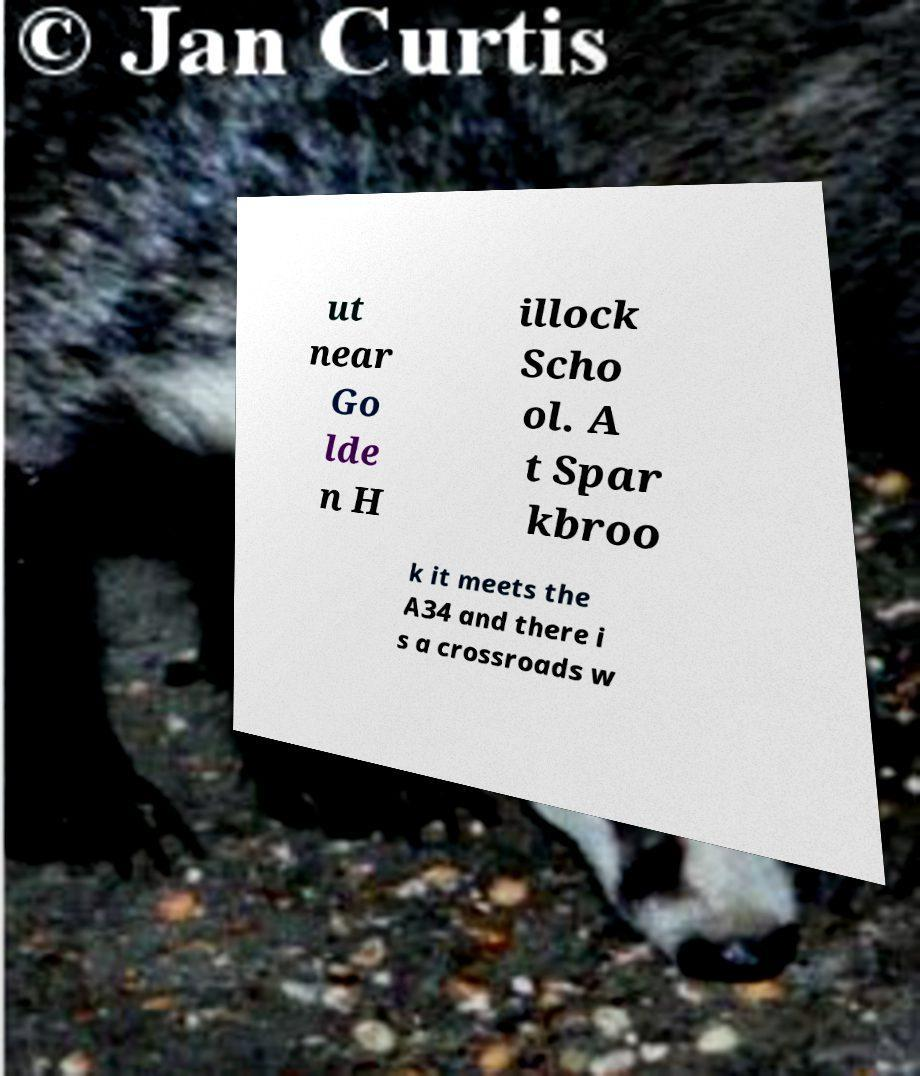There's text embedded in this image that I need extracted. Can you transcribe it verbatim? ut near Go lde n H illock Scho ol. A t Spar kbroo k it meets the A34 and there i s a crossroads w 